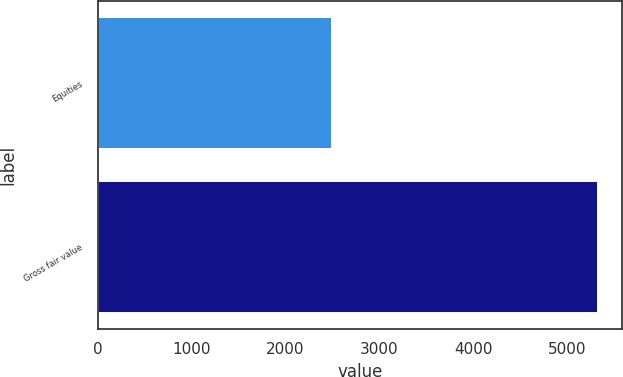Convert chart. <chart><loc_0><loc_0><loc_500><loc_500><bar_chart><fcel>Equities<fcel>Gross fair value<nl><fcel>2486<fcel>5314<nl></chart> 